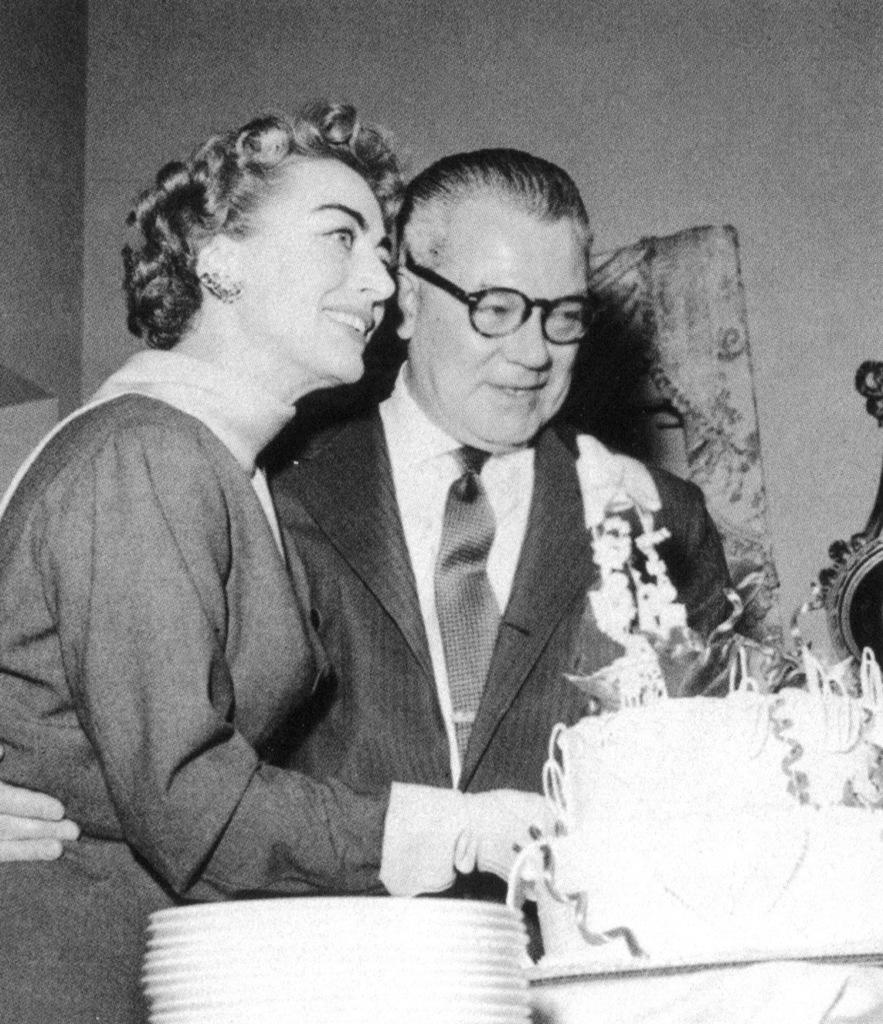Who are the people in the image? There is a man and a woman in the image. What expressions do the man and woman have in the image? Both the man and the woman are smiling in the image. What is the man wearing in the image? The man is wearing spectacles in the image. What is in front of the man and woman? There is a cake and plates in front of them. What type of oatmeal is being served on the plates in the image? There is no oatmeal present in the image; only a cake and plates are visible. Can you describe how the man and woman are touching each other in the image? There is no physical contact between the man and woman in the image; they are simply standing next to each other. 